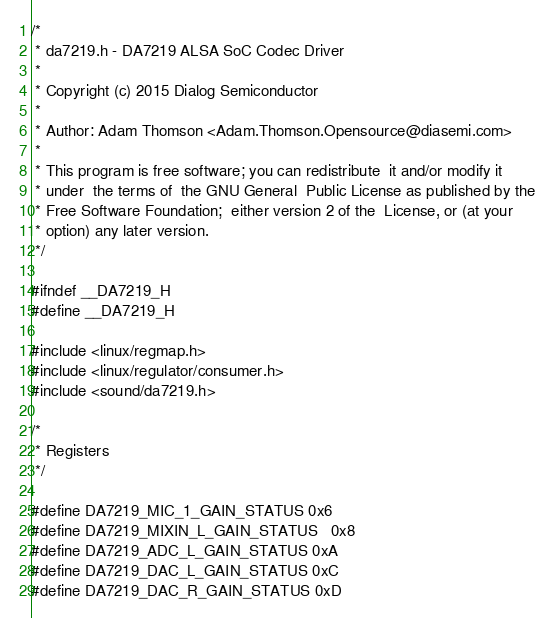Convert code to text. <code><loc_0><loc_0><loc_500><loc_500><_C_>/*
 * da7219.h - DA7219 ALSA SoC Codec Driver
 *
 * Copyright (c) 2015 Dialog Semiconductor
 *
 * Author: Adam Thomson <Adam.Thomson.Opensource@diasemi.com>
 *
 * This program is free software; you can redistribute  it and/or modify it
 * under  the terms of  the GNU General  Public License as published by the
 * Free Software Foundation;  either version 2 of the  License, or (at your
 * option) any later version.
 */

#ifndef __DA7219_H
#define __DA7219_H

#include <linux/regmap.h>
#include <linux/regulator/consumer.h>
#include <sound/da7219.h>

/*
 * Registers
 */

#define DA7219_MIC_1_GAIN_STATUS	0x6
#define DA7219_MIXIN_L_GAIN_STATUS	0x8
#define DA7219_ADC_L_GAIN_STATUS	0xA
#define DA7219_DAC_L_GAIN_STATUS	0xC
#define DA7219_DAC_R_GAIN_STATUS	0xD</code> 